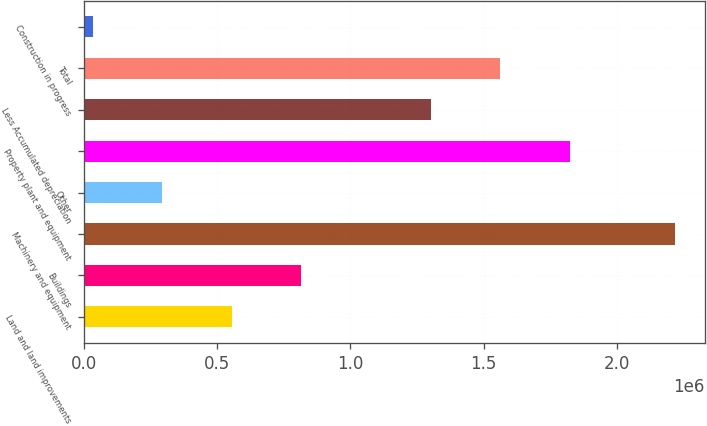Convert chart. <chart><loc_0><loc_0><loc_500><loc_500><bar_chart><fcel>Land and land improvements<fcel>Buildings<fcel>Machinery and equipment<fcel>Other<fcel>Property plant and equipment<fcel>Less Accumulated depreciation<fcel>Total<fcel>Construction in progress<nl><fcel>553876<fcel>815000<fcel>2.21946e+06<fcel>292753<fcel>1.82392e+06<fcel>1.30167e+06<fcel>1.56279e+06<fcel>31630<nl></chart> 